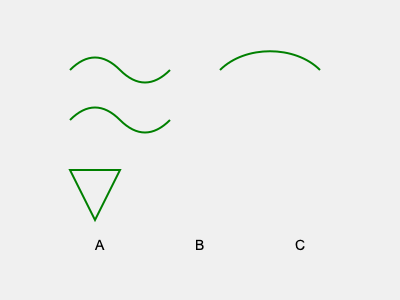Based on your knowledge of the rainforest trees, which leaf shape in the image corresponds to the sacred Ceiba tree, known for its spiritual significance in many tribal cultures? To answer this question, let's analyze the leaf shapes presented in the image:

1. Shape A (top left): This leaf has a wavy, undulating edge. It's characteristic of some rainforest trees, but not the Ceiba.

2. Shape B (middle): This leaf has a simple, oval shape with a pointed tip. Again, this is common in many rainforest trees, but not specific to the Ceiba.

3. Shape C (bottom left): This leaf has a distinctive triangular or arrow-like shape. This is the key identifier.

4. Shape D (right): This leaf has a curved, heart-like shape. It's not typical of the Ceiba tree.

The Ceiba tree, also known as the Kapok tree, is renowned for its spiritual significance in many Mesoamerican and South American cultures. It's often considered a sacred tree, representing a connection between the earthly and spiritual realms.

The Ceiba tree is easily recognizable by its distinctive leaf shape. The leaves are compound, meaning they are made up of multiple leaflets. Each leaflet has a characteristic triangular or arrow-like shape, which matches Shape C in the image.

This triangular shape allows for efficient water runoff during heavy tropical rains, a common adaptation in rainforest trees. It also maximizes sunlight exposure, which is crucial in the competitive canopy environment of the rainforest.

Therefore, based on the traditional knowledge passed down through generations and the distinctive leaf shape, we can conclude that Shape C represents the leaf of the sacred Ceiba tree.
Answer: C 